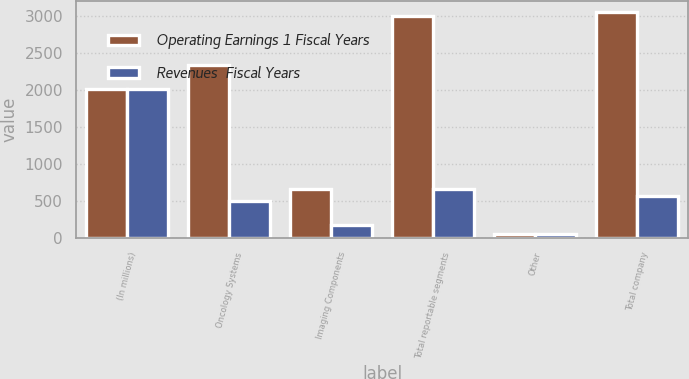Convert chart to OTSL. <chart><loc_0><loc_0><loc_500><loc_500><stacked_bar_chart><ecel><fcel>(In millions)<fcel>Oncology Systems<fcel>Imaging Components<fcel>Total reportable segments<fcel>Other<fcel>Total company<nl><fcel>Operating Earnings 1 Fiscal Years<fcel>2014<fcel>2344.2<fcel>660.2<fcel>3004.4<fcel>45.4<fcel>3049.8<nl><fcel>Revenues  Fiscal Years<fcel>2014<fcel>495.5<fcel>169.9<fcel>665.4<fcel>52.7<fcel>571.2<nl></chart> 